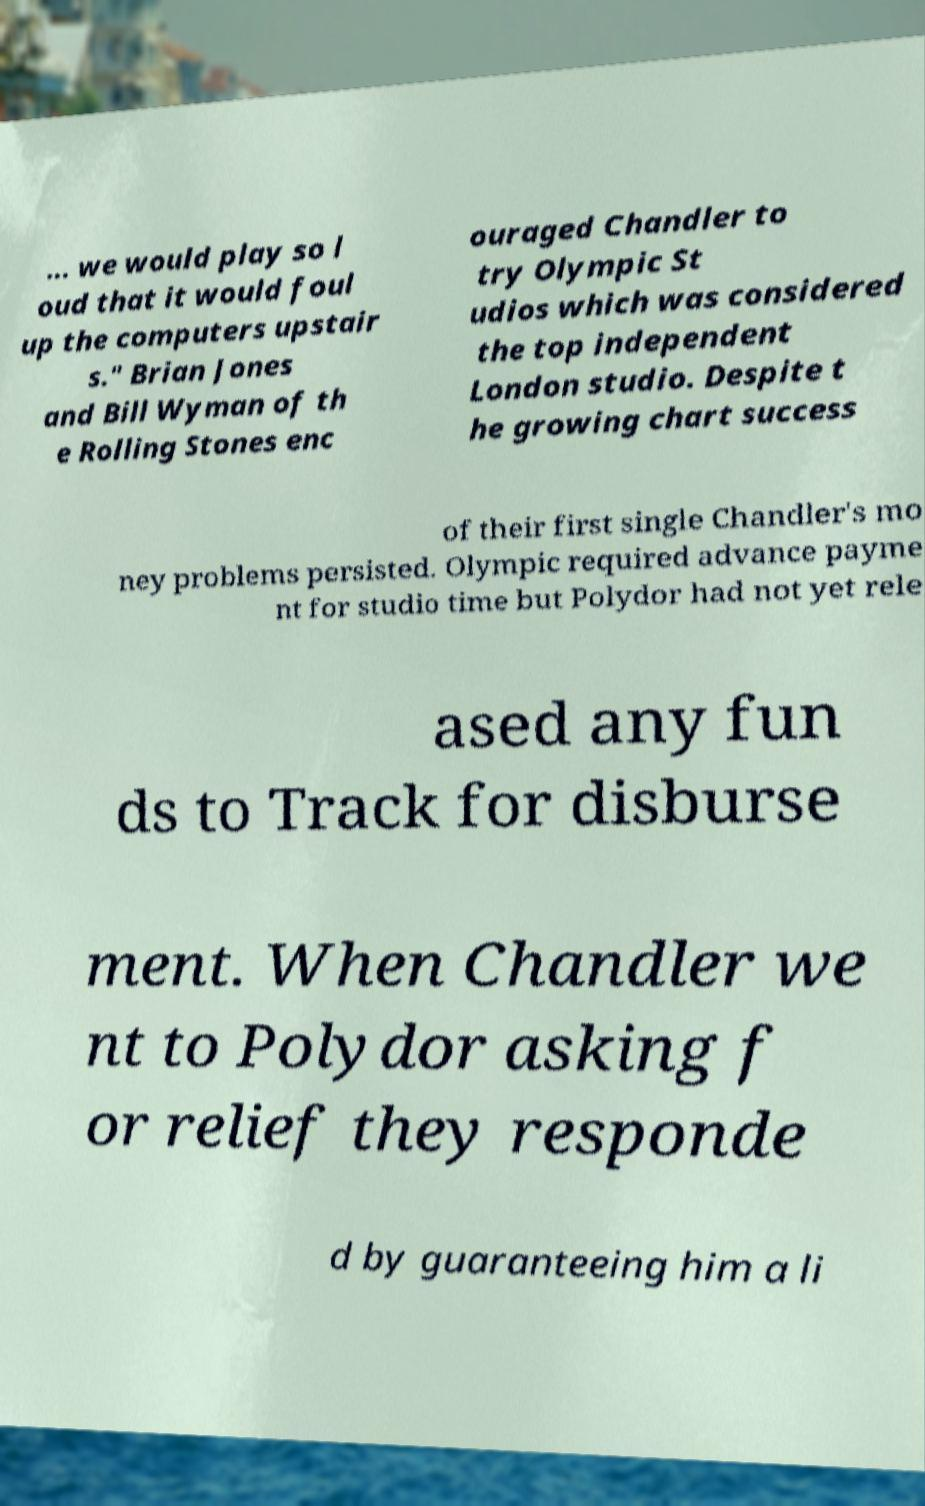Could you extract and type out the text from this image? ... we would play so l oud that it would foul up the computers upstair s." Brian Jones and Bill Wyman of th e Rolling Stones enc ouraged Chandler to try Olympic St udios which was considered the top independent London studio. Despite t he growing chart success of their first single Chandler's mo ney problems persisted. Olympic required advance payme nt for studio time but Polydor had not yet rele ased any fun ds to Track for disburse ment. When Chandler we nt to Polydor asking f or relief they responde d by guaranteeing him a li 